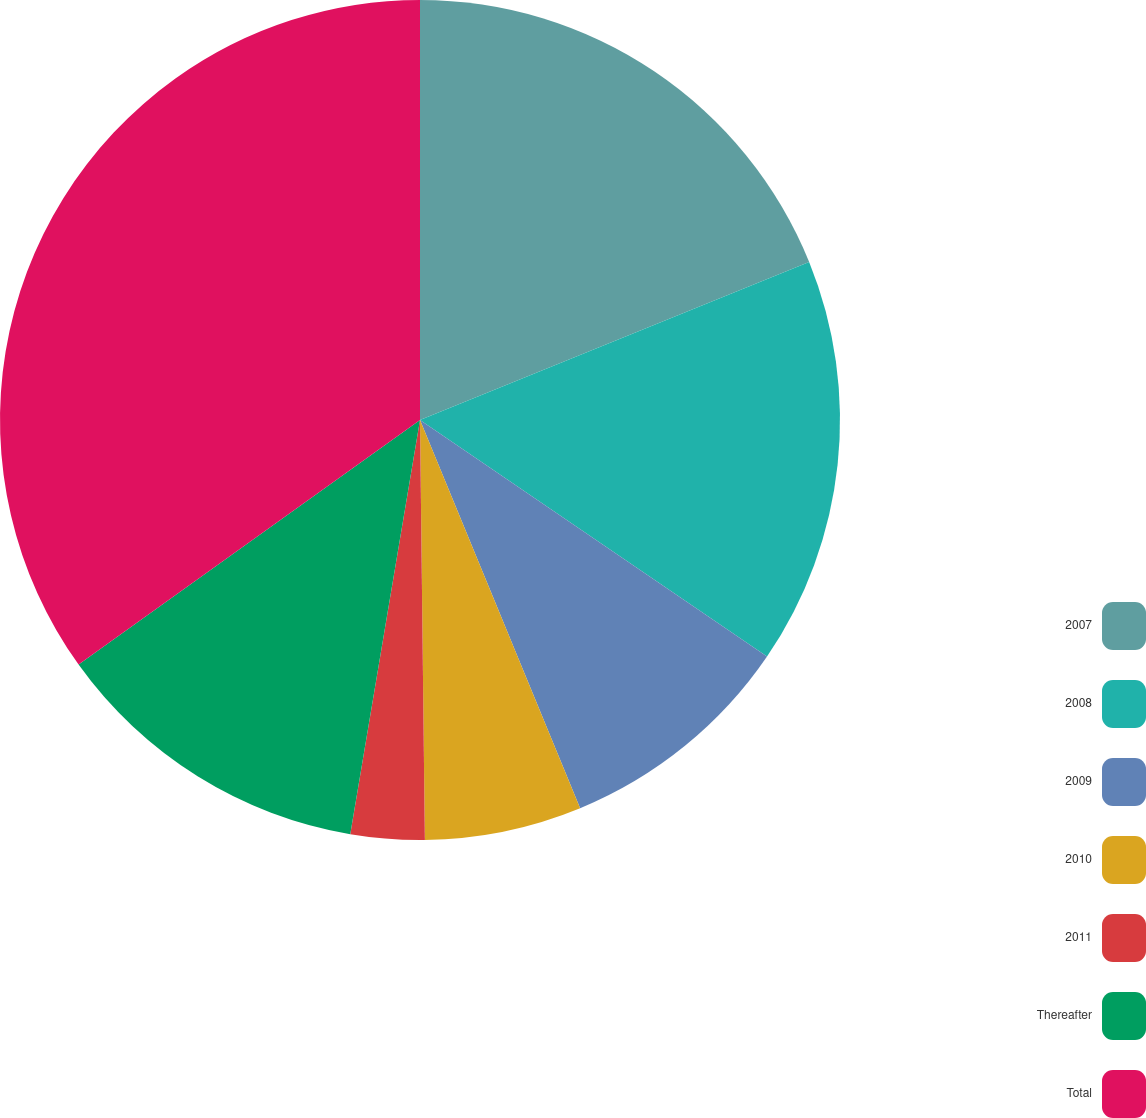Convert chart. <chart><loc_0><loc_0><loc_500><loc_500><pie_chart><fcel>2007<fcel>2008<fcel>2009<fcel>2010<fcel>2011<fcel>Thereafter<fcel>Total<nl><fcel>18.86%<fcel>15.66%<fcel>9.25%<fcel>6.04%<fcel>2.84%<fcel>12.45%<fcel>34.89%<nl></chart> 